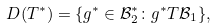<formula> <loc_0><loc_0><loc_500><loc_500>D ( T ^ { * } ) = \{ g ^ { * } \in \mathcal { B } _ { 2 } ^ { * } \colon g ^ { * } T \mathcal { B } _ { 1 } \} ,</formula> 